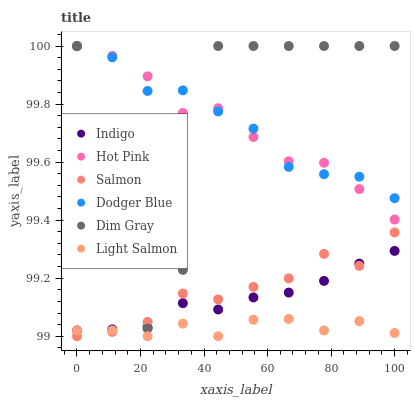Does Light Salmon have the minimum area under the curve?
Answer yes or no. Yes. Does Dim Gray have the maximum area under the curve?
Answer yes or no. Yes. Does Indigo have the minimum area under the curve?
Answer yes or no. No. Does Indigo have the maximum area under the curve?
Answer yes or no. No. Is Indigo the smoothest?
Answer yes or no. Yes. Is Dim Gray the roughest?
Answer yes or no. Yes. Is Dim Gray the smoothest?
Answer yes or no. No. Is Indigo the roughest?
Answer yes or no. No. Does Light Salmon have the lowest value?
Answer yes or no. Yes. Does Dim Gray have the lowest value?
Answer yes or no. No. Does Dodger Blue have the highest value?
Answer yes or no. Yes. Does Indigo have the highest value?
Answer yes or no. No. Is Indigo less than Dodger Blue?
Answer yes or no. Yes. Is Dodger Blue greater than Light Salmon?
Answer yes or no. Yes. Does Dodger Blue intersect Dim Gray?
Answer yes or no. Yes. Is Dodger Blue less than Dim Gray?
Answer yes or no. No. Is Dodger Blue greater than Dim Gray?
Answer yes or no. No. Does Indigo intersect Dodger Blue?
Answer yes or no. No. 